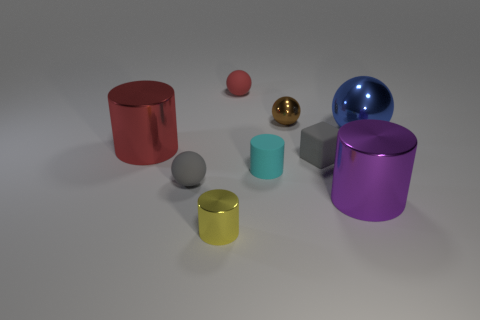Subtract all metallic cylinders. How many cylinders are left? 1 Subtract all blue balls. How many balls are left? 3 Subtract 1 blocks. How many blocks are left? 0 Subtract 0 blue cylinders. How many objects are left? 9 Subtract all cylinders. How many objects are left? 5 Subtract all blue spheres. Subtract all blue cylinders. How many spheres are left? 3 Subtract all yellow cylinders. Subtract all gray things. How many objects are left? 6 Add 5 red cylinders. How many red cylinders are left? 6 Add 5 cylinders. How many cylinders exist? 9 